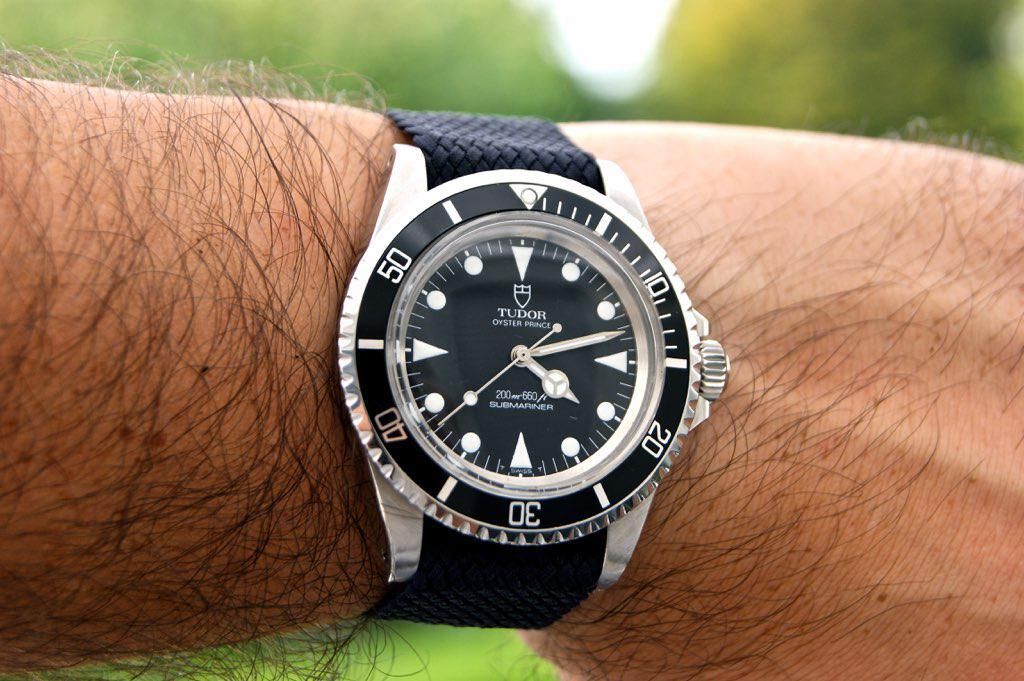<image>
Summarize the visual content of the image. A Tudor Submariner brand watch, model Oyster Prince. 